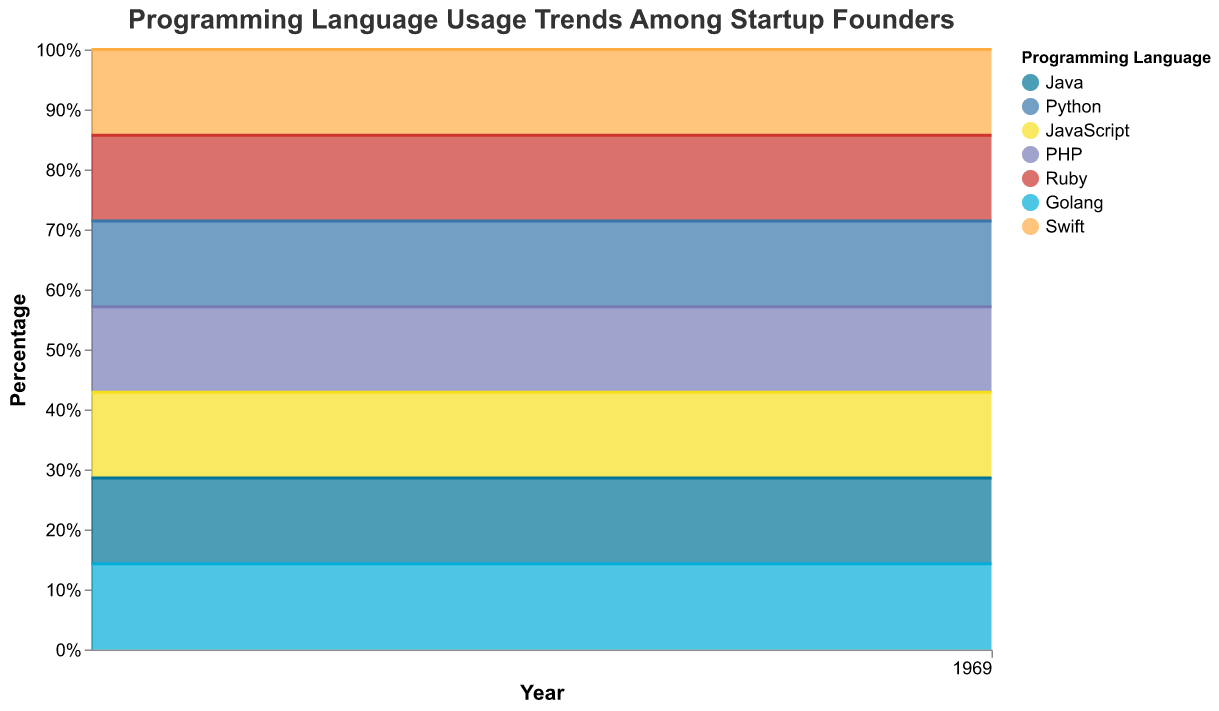What's the title of the chart? The title is usually found at the top of the chart to provide context. In this instance, the title text is visible and mentions the key subject of the graph.
Answer: "Programming Language Usage Trends Among Startup Founders" What does the y-axis represent? The y-axis shows the percentage usage of different programming languages among startup founders over time. It uses normalization to make sure each year's percentages add up to 100%.
Answer: Percentage Which programming language had the highest usage in 2013? By looking at the first year in the chart, the section with the largest area at the bottom typically indicates the highest usage. Java occupies the largest area in 2013.
Answer: Java How did JavaScript usage change from 2013 to 2022? By following the section of the area chart corresponding to JavaScript's color from 2013 to 2022, you can observe its change in width, indicating an increase.
Answer: Increased Which two languages had almost equal usage in 2015? By examining the 2015 data points, you can compare the sizes of different sections. Python and Java have nearly similar sections in the 2015 stack.
Answer: Python and Java Compare the usage of Ruby and Golang in 2020. To compare, look at the areas corresponding to Ruby and Golang in 2020. Golang's section is larger than Ruby's, indicating higher usage for Golang.
Answer: Golang had higher usage than Ruby What is the trend for PHP usage over the decade? By tracking PHP's section from 2013 to 2022, you can see if it increased or decreased in size. PHP shows a downward trend.
Answer: Decreased What's the difference in JavaScript usage between 2016 and 2020? Identifying the JavaScript sections in 2016 and 2020, calculate the increase or decrease by comparing the widths of these sections.
Answer: Increased Has Python surpassed Java in terms of usage over the years? By observing areas for Python and Java from 2013 to 2022, you can notice that Python starts smaller than Java in 2013 but grows larger by 2022.
Answer: Yes Which language showed slight usage decline towards the end of the decade? Check the trends of all sections and identify any language that has shown a decrease from 2019 to 2022. Swift shows a small decline in that period.
Answer: Swift 